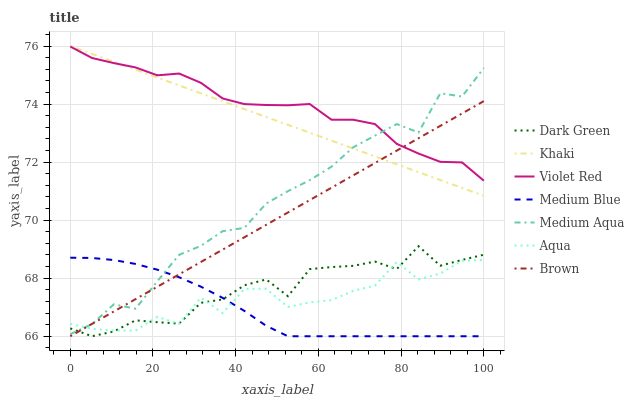Does Medium Blue have the minimum area under the curve?
Answer yes or no. Yes. Does Violet Red have the maximum area under the curve?
Answer yes or no. Yes. Does Khaki have the minimum area under the curve?
Answer yes or no. No. Does Khaki have the maximum area under the curve?
Answer yes or no. No. Is Brown the smoothest?
Answer yes or no. Yes. Is Aqua the roughest?
Answer yes or no. Yes. Is Violet Red the smoothest?
Answer yes or no. No. Is Violet Red the roughest?
Answer yes or no. No. Does Khaki have the lowest value?
Answer yes or no. No. Does Violet Red have the highest value?
Answer yes or no. No. Is Aqua less than Khaki?
Answer yes or no. Yes. Is Khaki greater than Aqua?
Answer yes or no. Yes. Does Aqua intersect Khaki?
Answer yes or no. No. 